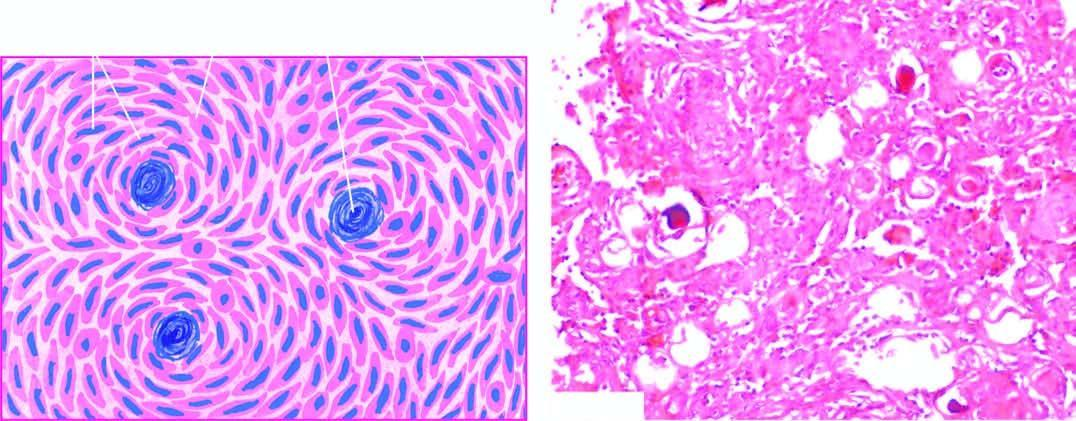what do the cells have?
Answer the question using a single word or phrase. Features of both syncytial and fibroblastic type and form whorled appearance 